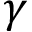Convert formula to latex. <formula><loc_0><loc_0><loc_500><loc_500>\gamma</formula> 